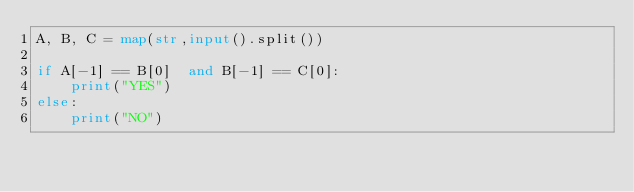Convert code to text. <code><loc_0><loc_0><loc_500><loc_500><_Python_>A, B, C = map(str,input().split())

if A[-1] == B[0]  and B[-1] == C[0]:
    print("YES")
else:
    print("NO")</code> 